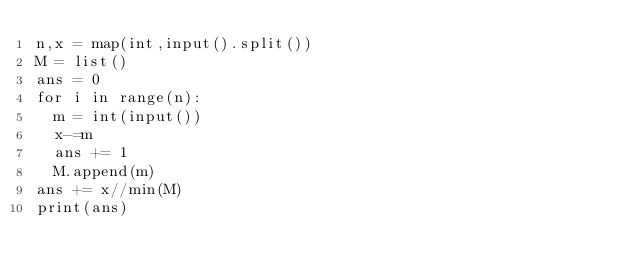<code> <loc_0><loc_0><loc_500><loc_500><_Python_>n,x = map(int,input().split())
M = list()
ans = 0
for i in range(n):
  m = int(input())
  x-=m
  ans += 1
  M.append(m)
ans += x//min(M)
print(ans)</code> 